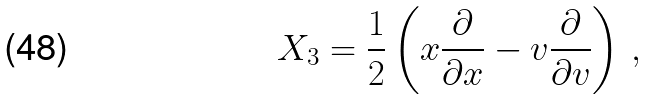<formula> <loc_0><loc_0><loc_500><loc_500>X _ { 3 } = \frac { 1 } { 2 } \left ( x \frac { \partial } { \partial x } - v \frac { \partial } { \partial v } \right ) \, ,</formula> 